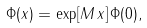<formula> <loc_0><loc_0><loc_500><loc_500>\Phi ( x ) = \exp [ M \, x ] \, \Phi ( 0 ) ,</formula> 